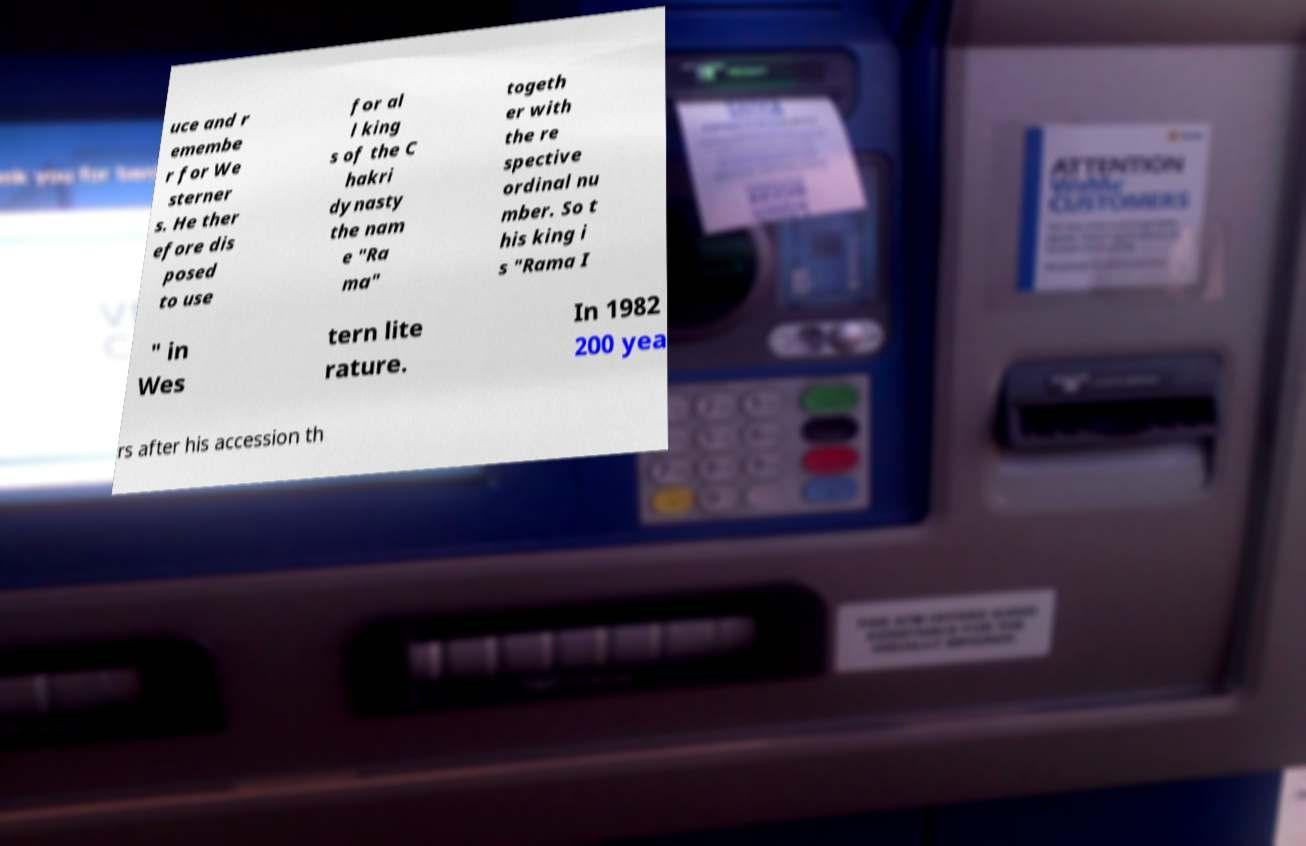Could you extract and type out the text from this image? uce and r emembe r for We sterner s. He ther efore dis posed to use for al l king s of the C hakri dynasty the nam e "Ra ma" togeth er with the re spective ordinal nu mber. So t his king i s "Rama I " in Wes tern lite rature. In 1982 200 yea rs after his accession th 